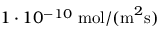Convert formula to latex. <formula><loc_0><loc_0><loc_500><loc_500>1 \cdot 1 0 ^ { - 1 0 } \, m o l / ( m ^ { 2 } s )</formula> 